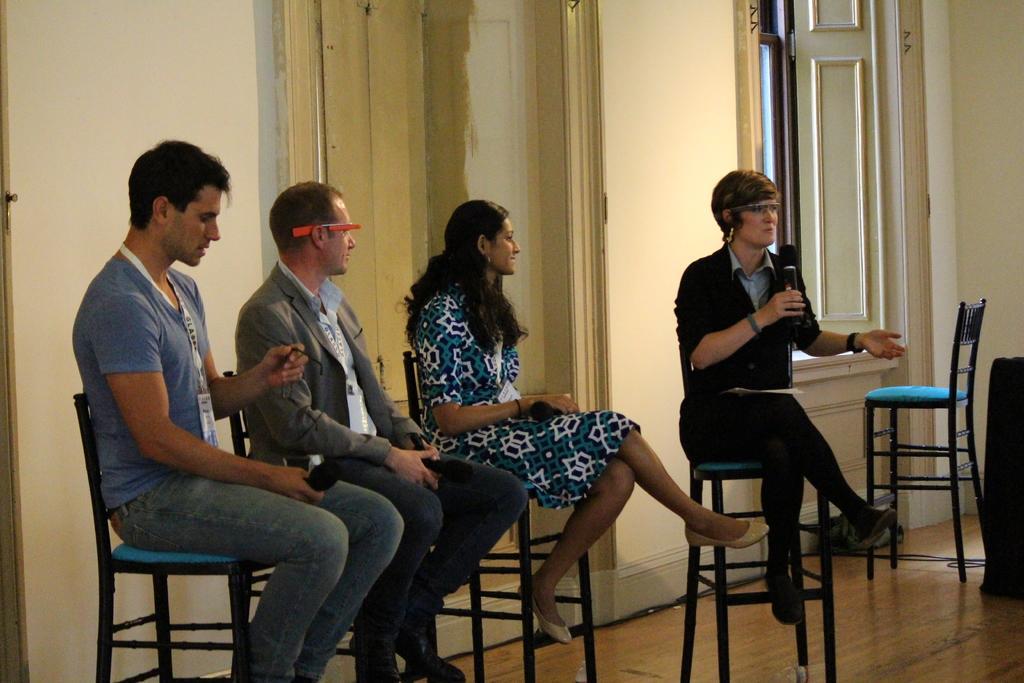In one or two sentences, can you explain what this image depicts? This picture shows a group of people seated on the chairs and we see a woman speaking with the help of a microphone in her hand 